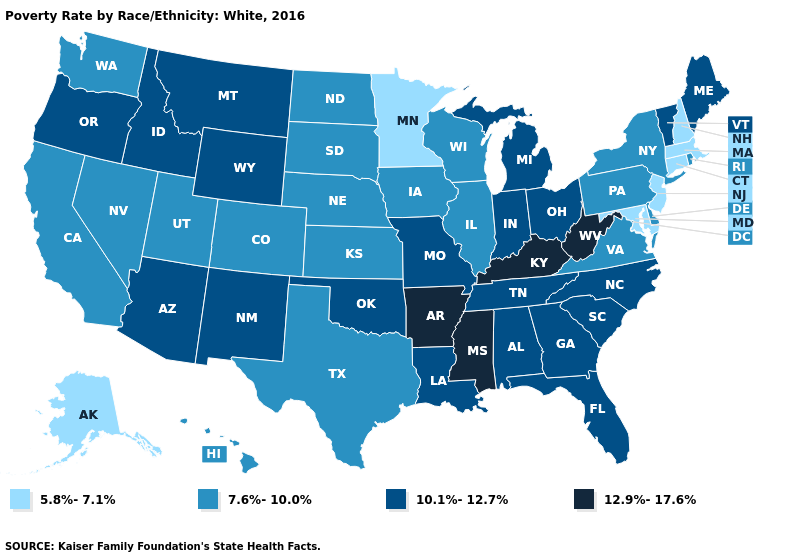Name the states that have a value in the range 7.6%-10.0%?
Give a very brief answer. California, Colorado, Delaware, Hawaii, Illinois, Iowa, Kansas, Nebraska, Nevada, New York, North Dakota, Pennsylvania, Rhode Island, South Dakota, Texas, Utah, Virginia, Washington, Wisconsin. What is the lowest value in the South?
Be succinct. 5.8%-7.1%. What is the highest value in the West ?
Concise answer only. 10.1%-12.7%. What is the lowest value in the USA?
Be succinct. 5.8%-7.1%. Name the states that have a value in the range 10.1%-12.7%?
Keep it brief. Alabama, Arizona, Florida, Georgia, Idaho, Indiana, Louisiana, Maine, Michigan, Missouri, Montana, New Mexico, North Carolina, Ohio, Oklahoma, Oregon, South Carolina, Tennessee, Vermont, Wyoming. What is the value of North Carolina?
Write a very short answer. 10.1%-12.7%. What is the highest value in the Northeast ?
Keep it brief. 10.1%-12.7%. What is the value of Indiana?
Be succinct. 10.1%-12.7%. What is the value of Idaho?
Answer briefly. 10.1%-12.7%. What is the lowest value in the USA?
Concise answer only. 5.8%-7.1%. Name the states that have a value in the range 5.8%-7.1%?
Be succinct. Alaska, Connecticut, Maryland, Massachusetts, Minnesota, New Hampshire, New Jersey. What is the value of Kentucky?
Write a very short answer. 12.9%-17.6%. What is the value of South Dakota?
Keep it brief. 7.6%-10.0%. What is the value of New Jersey?
Be succinct. 5.8%-7.1%. 